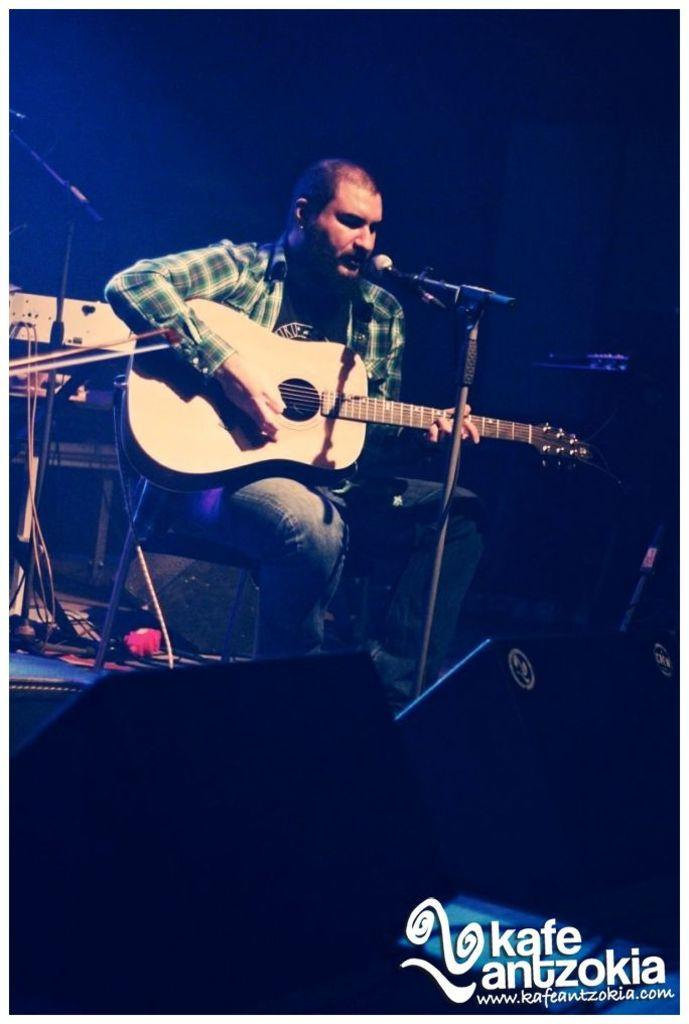Who is the main subject in the image? There is a man in the image. What is the man doing in the image? The man is sitting on a chair, playing the guitar, and singing. What type of bun is the man using to whistle in the image? There is no bun or whistling activity present in the image. 